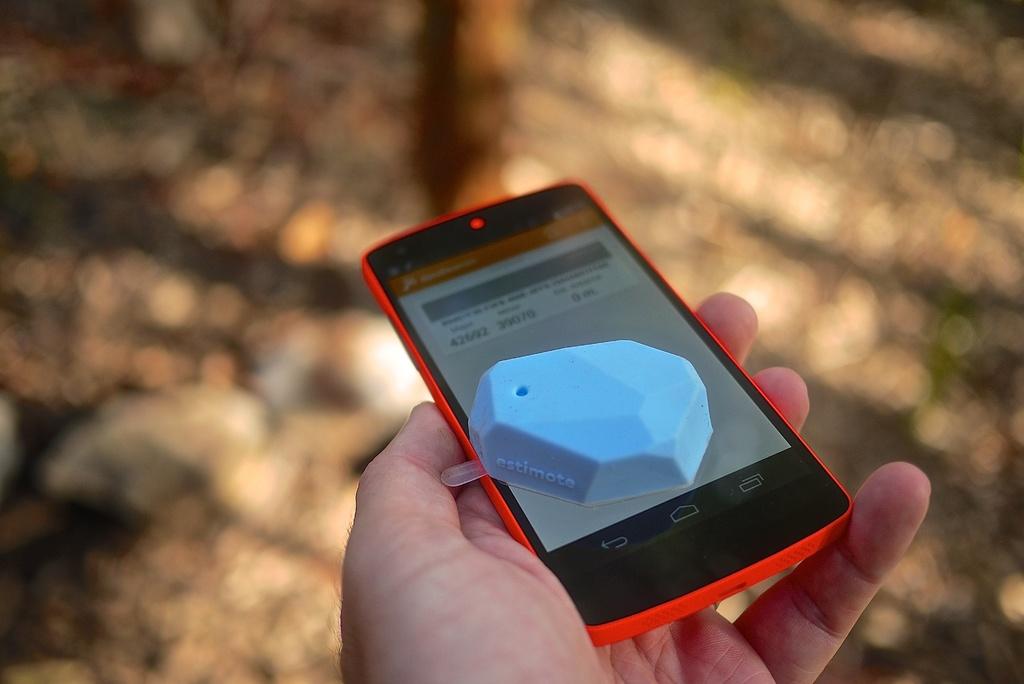What brand is the blue object?
Offer a very short reply. Estimote. 